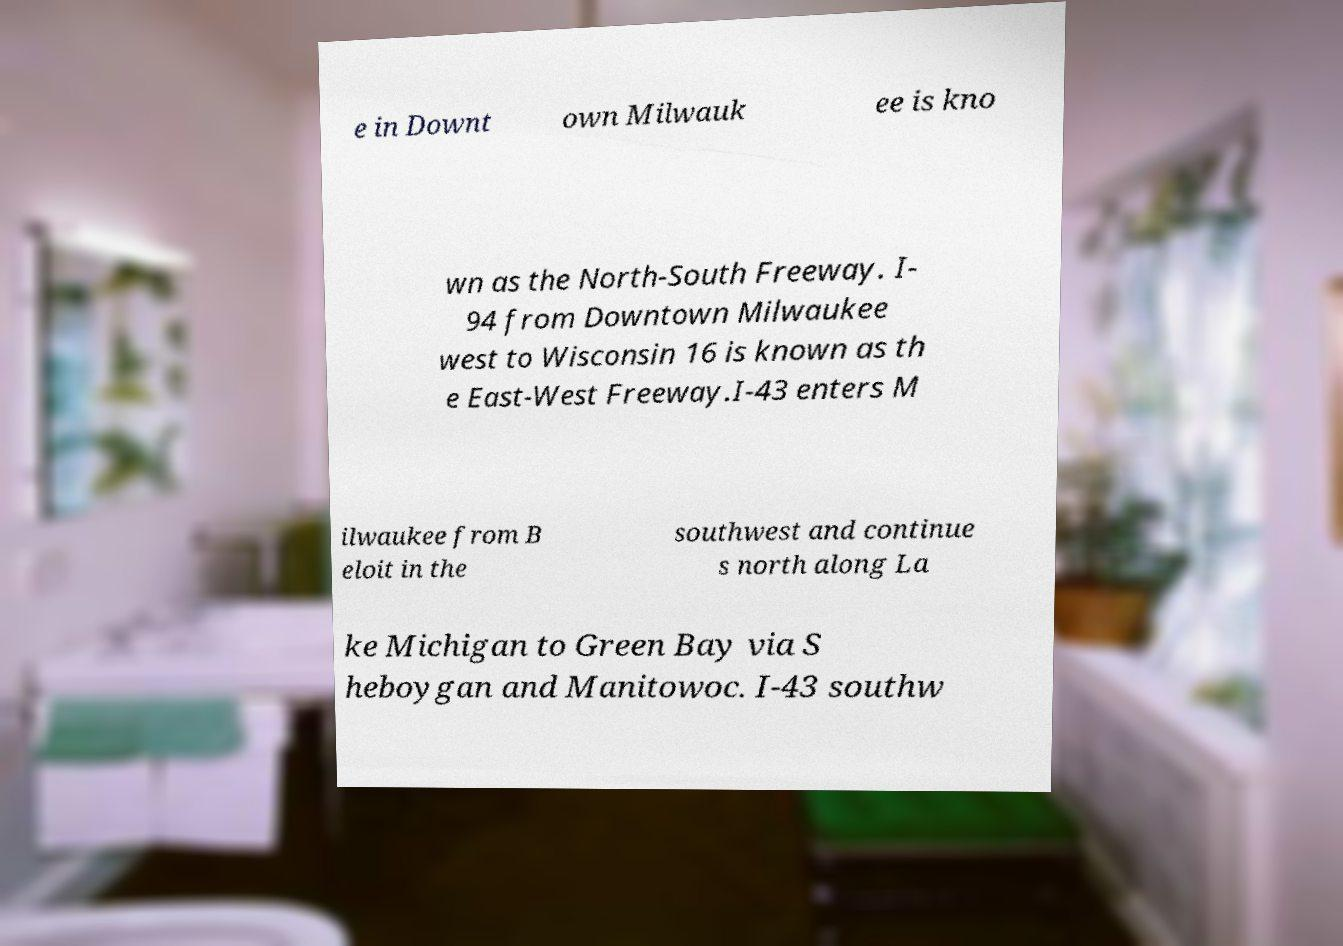Please identify and transcribe the text found in this image. e in Downt own Milwauk ee is kno wn as the North-South Freeway. I- 94 from Downtown Milwaukee west to Wisconsin 16 is known as th e East-West Freeway.I-43 enters M ilwaukee from B eloit in the southwest and continue s north along La ke Michigan to Green Bay via S heboygan and Manitowoc. I-43 southw 